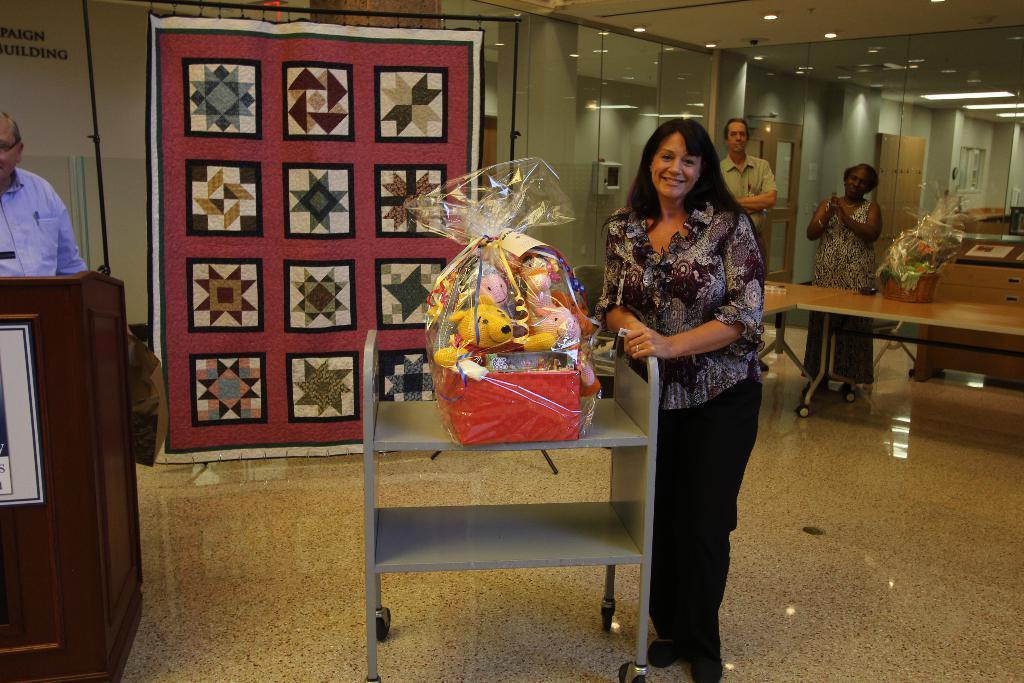Can you describe this image briefly? In the foreground, I can see four persons are standing on the floor in front of tables and I can see some objects on a table. In the background, I can see a wall, boards, lights on a rooftop and doors. This image taken, maybe in a hall. 